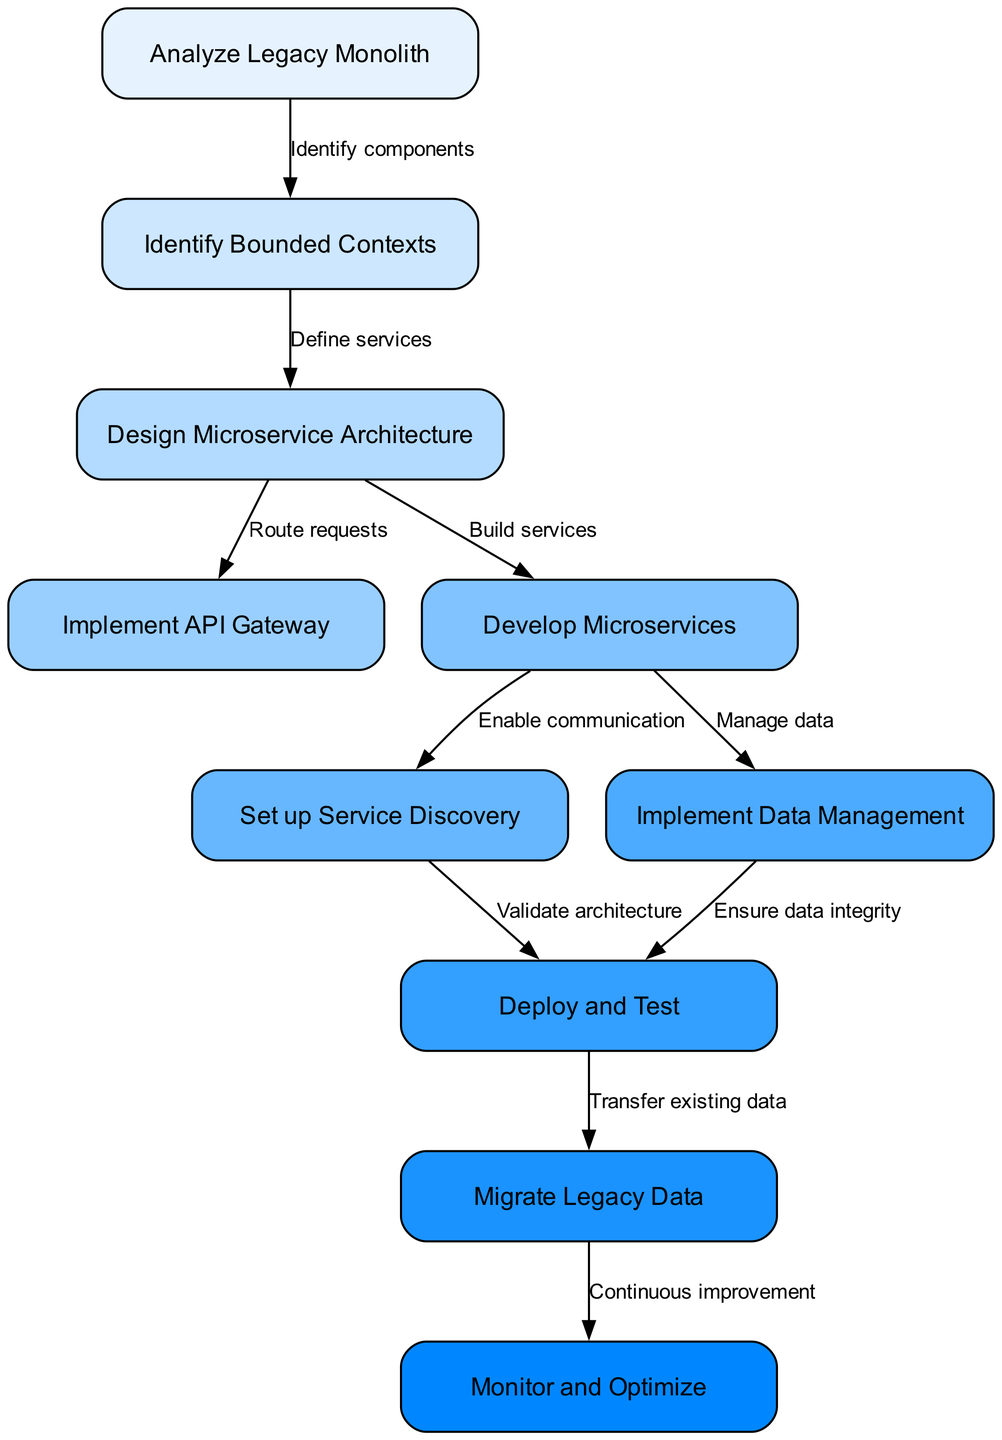What is the first step in the flowchart? The first node in the diagram is labeled "Analyze Legacy Monolith," indicating it is the starting point for the microservice architecture implementation process.
Answer: Analyze Legacy Monolith How many nodes are in the flowchart? By counting the nodes listed in the data, there are a total of ten nodes that represent the various steps in the microservice architecture implementation.
Answer: 10 What is the last step before monitoring and optimizing? The last step before reaching "Monitor and Optimize" is "Migrate Legacy Data," as indicated by the flow from node nine to node ten.
Answer: Migrate Legacy Data Which two nodes are directly connected by the edge saying "Define services"? The edge labeled "Define services" connects node two ("Identify Bounded Contexts") to node three ("Design Microservice Architecture") as shown in the data structure.
Answer: Identify Bounded Contexts and Design Microservice Architecture What action follows the development of microservices? After "Develop Microservices," the next action according to the flowchart is to "Set up Service Discovery," which facilitates communication between the services.
Answer: Set up Service Discovery What text labels the edge that connects "Design Microservice Architecture" to "Implement API Gateway"? The edge connecting these nodes is labeled "Route requests," which describes the action taken to manage how requests are handled in the architecture.
Answer: Route requests Which node is responsible for ensuring data integrity? The node labeled "Implement Data Management" is tasked with ensuring data integrity as it is connected to "Deploy and Test" in the flowchart.
Answer: Implement Data Management How many edges are there in total in the diagram? There are a total of nine edges according to the list, each showing directional relationships between the nodes involved in transitioning through steps.
Answer: 9 